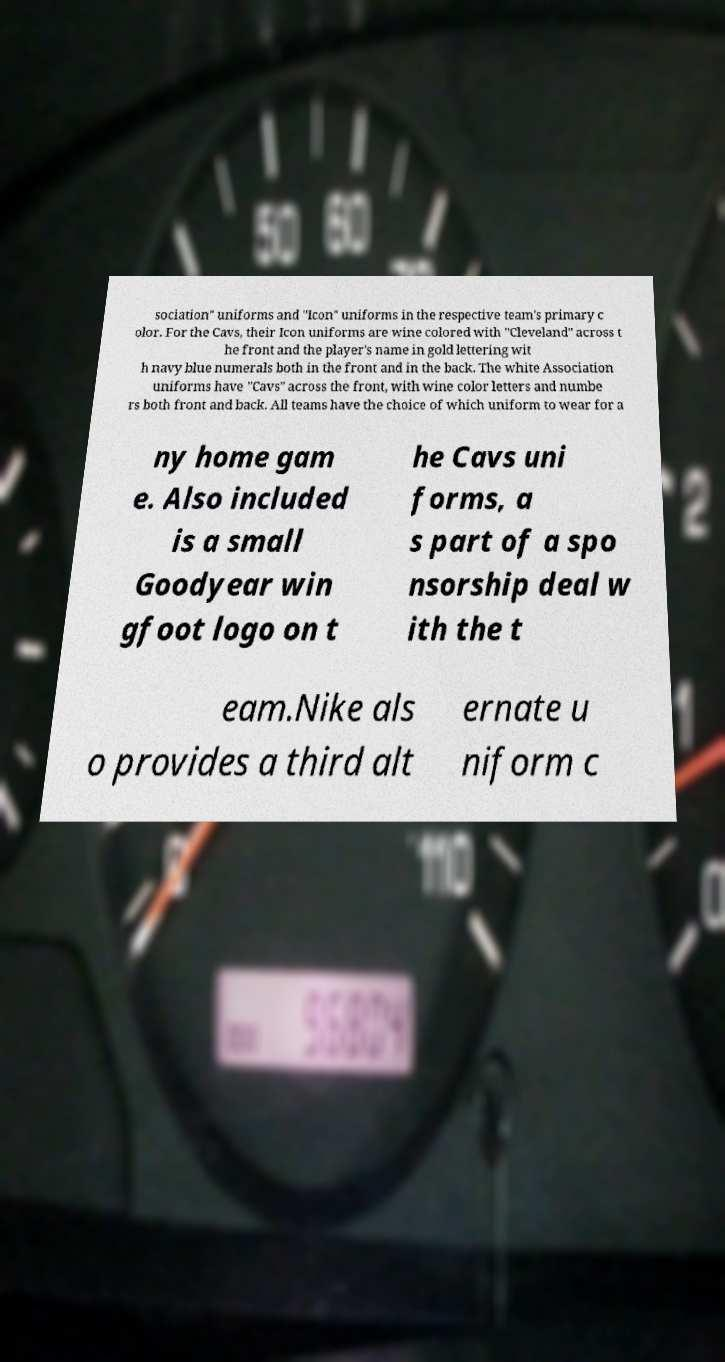What messages or text are displayed in this image? I need them in a readable, typed format. sociation" uniforms and "Icon" uniforms in the respective team's primary c olor. For the Cavs, their Icon uniforms are wine colored with "Cleveland" across t he front and the player's name in gold lettering wit h navy blue numerals both in the front and in the back. The white Association uniforms have "Cavs" across the front, with wine color letters and numbe rs both front and back. All teams have the choice of which uniform to wear for a ny home gam e. Also included is a small Goodyear win gfoot logo on t he Cavs uni forms, a s part of a spo nsorship deal w ith the t eam.Nike als o provides a third alt ernate u niform c 